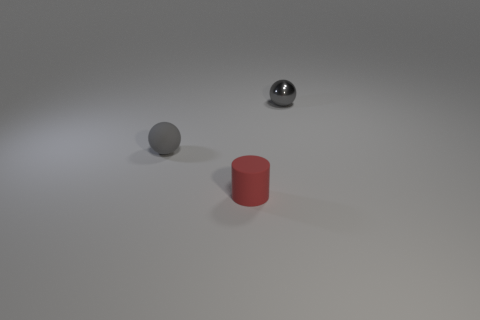Does the metal thing have the same color as the rubber thing behind the cylinder?
Your answer should be very brief. Yes. There is a shiny thing behind the thing in front of the thing on the left side of the tiny red matte cylinder; what color is it?
Your answer should be compact. Gray. Is there a tiny rubber thing of the same shape as the gray shiny thing?
Provide a succinct answer. Yes. What is the color of the matte object that is the same size as the rubber cylinder?
Make the answer very short. Gray. What material is the tiny gray thing that is to the left of the red rubber object?
Make the answer very short. Rubber. There is a thing in front of the gray rubber thing; does it have the same shape as the gray thing that is in front of the tiny gray metal thing?
Make the answer very short. No. Are there the same number of tiny gray balls that are to the right of the small metal sphere and gray rubber cylinders?
Your response must be concise. Yes. What number of red objects are made of the same material as the tiny cylinder?
Offer a terse response. 0. There is a thing that is the same material as the small red cylinder; what is its color?
Give a very brief answer. Gray. There is a rubber ball; is it the same size as the gray sphere that is on the right side of the cylinder?
Offer a very short reply. Yes. 